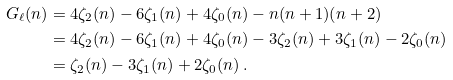<formula> <loc_0><loc_0><loc_500><loc_500>G _ { \ell } ( n ) & = 4 \zeta _ { 2 } ( n ) - 6 \zeta _ { 1 } ( n ) + 4 \zeta _ { 0 } ( n ) - n ( n + 1 ) ( n + 2 ) \\ & = 4 \zeta _ { 2 } ( n ) - 6 \zeta _ { 1 } ( n ) + 4 \zeta _ { 0 } ( n ) - 3 \zeta _ { 2 } ( n ) + 3 \zeta _ { 1 } ( n ) - 2 \zeta _ { 0 } ( n ) \\ & = \zeta _ { 2 } ( n ) - 3 \zeta _ { 1 } ( n ) + 2 \zeta _ { 0 } ( n ) \, .</formula> 